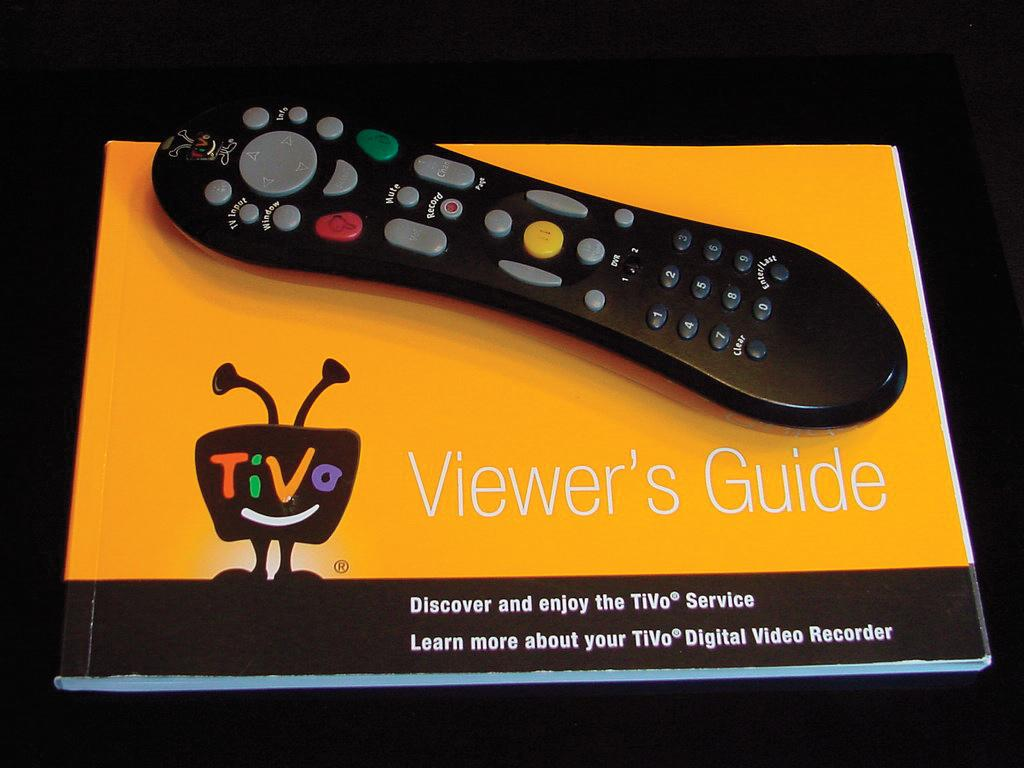<image>
Describe the image concisely. A tivo viewer's guide and a remote on top. 